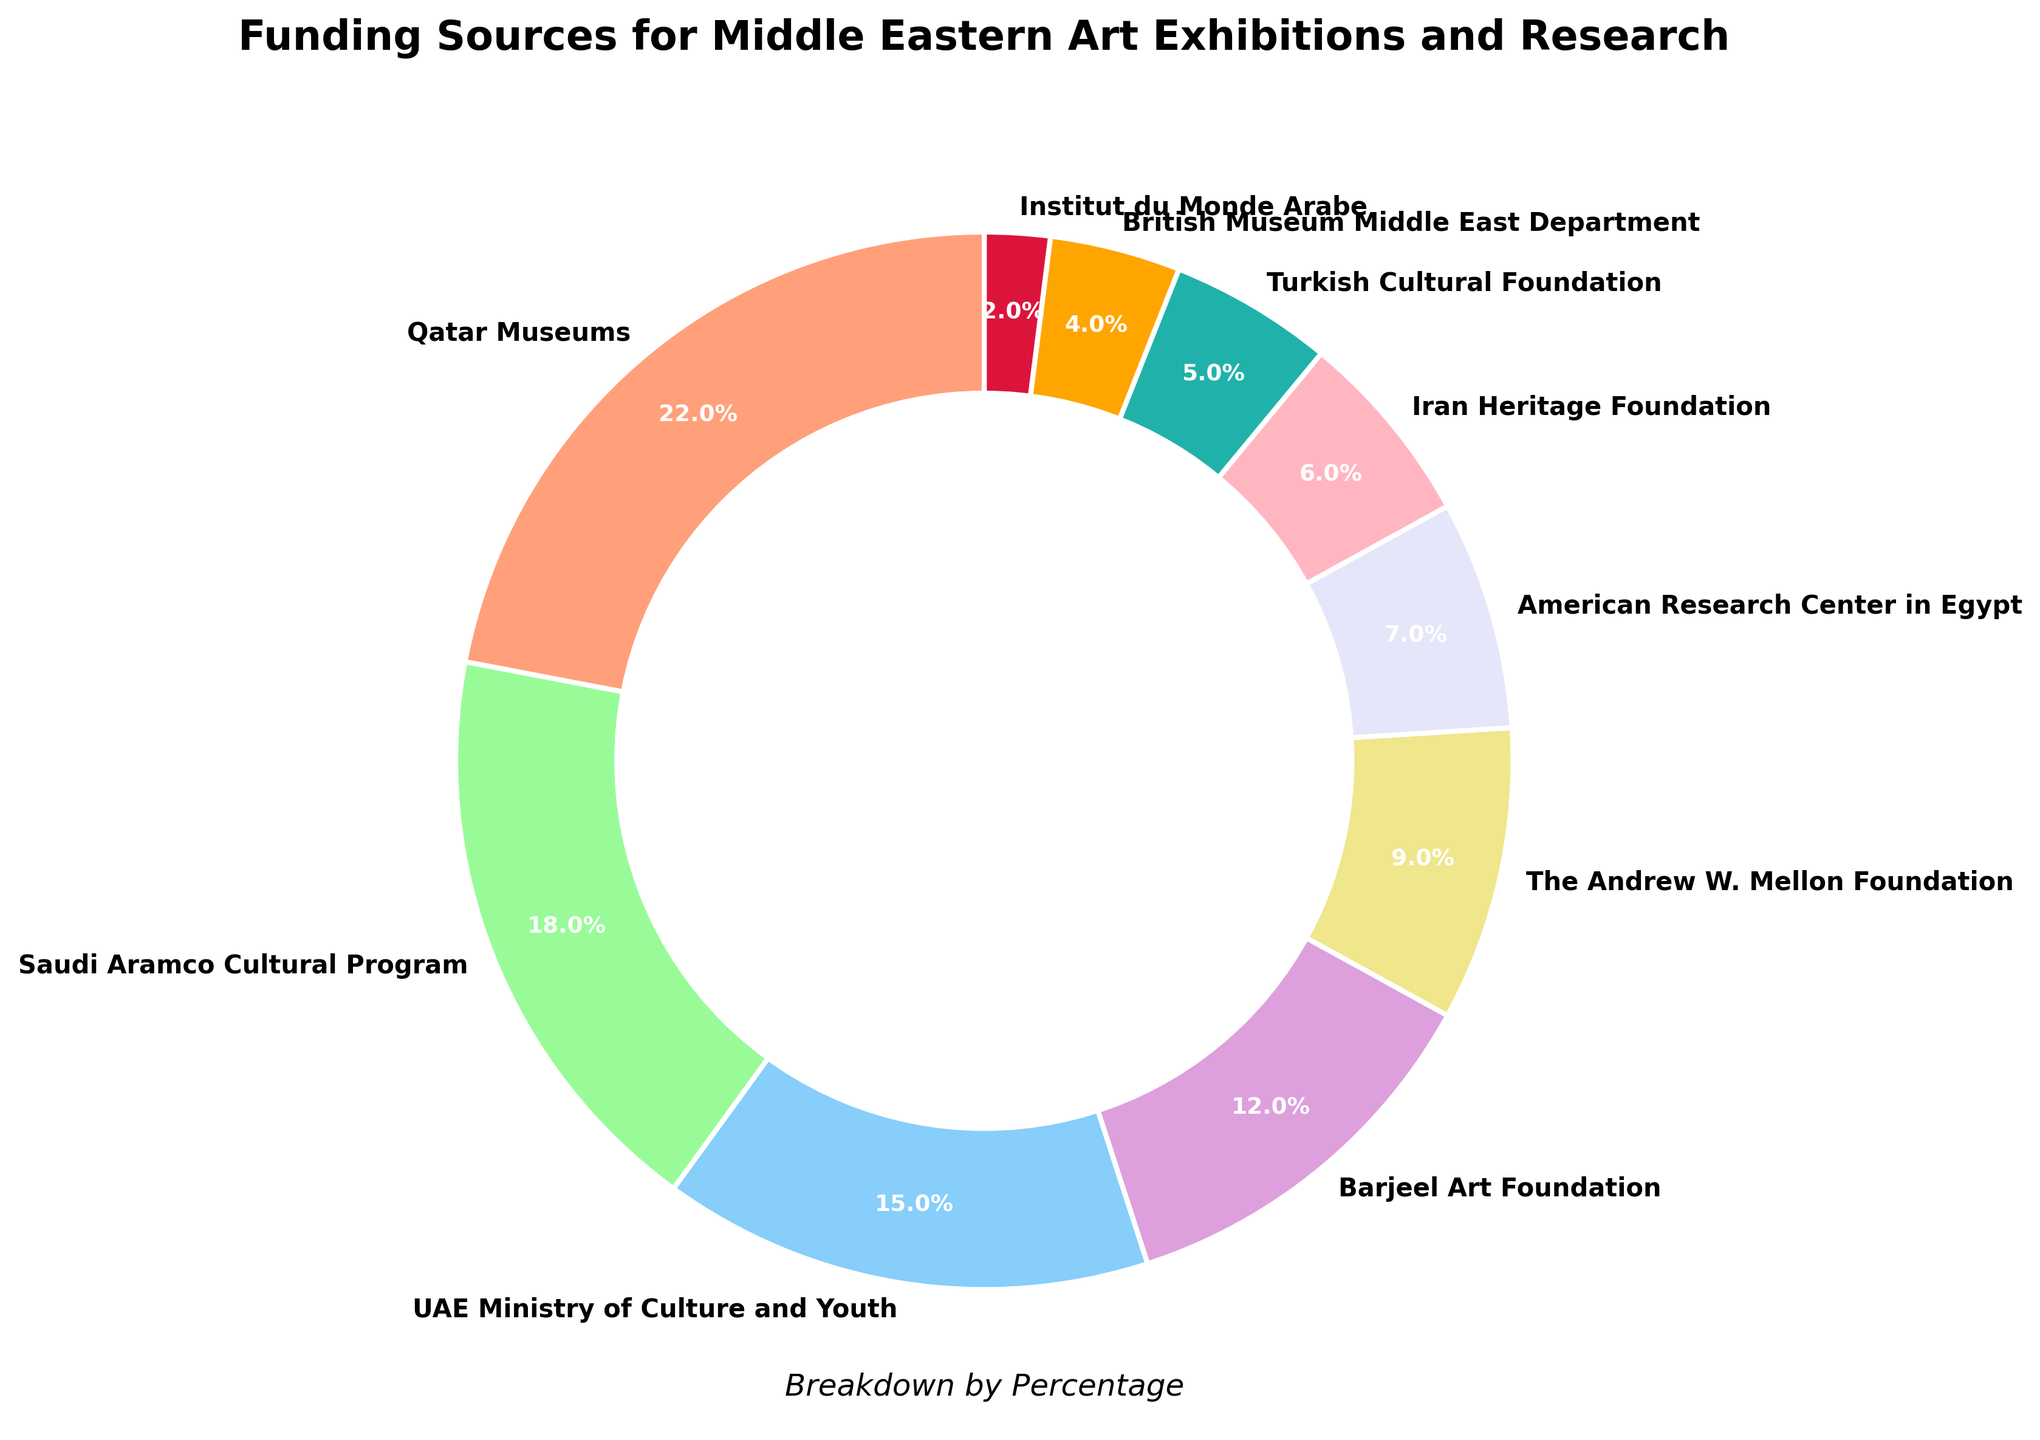What is the percentage of funding provided by the Qatar Museums? Locate the label "Qatar Museums" on the pie chart, which shows the corresponding percentage as 22%.
Answer: 22% Which funding source contributes the least to Middle Eastern art exhibitions and research? Find the slice of the pie chart with the smallest percentage, labeled "Institut du Monde Arabe," contributing 2%.
Answer: Institut du Monde Arabe How much more funding does the Qatar Museums provide compared to the British Museum Middle East Department? Subtract the percentage of the British Museum Middle East Department (4%) from the Qatar Museums (22%). The difference is 22% - 4% = 18%.
Answer: 18% What is the total percentage of funding from non-Middle Eastern sources? Sum the percentages of The Andrew W. Mellon Foundation (9%), American Research Center in Egypt (7%), and Institut du Monde Arabe (2%) which totals 9% + 7% + 2% = 18%.
Answer: 18% Which three funding sources contribute the most to Middle Eastern art exhibitions and research? Identify the top three largest slices on the pie chart. The largest slices are Qatar Museums (22%), Saudi Aramco Cultural Program (18%), and UAE Ministry of Culture and Youth (15%).
Answer: Qatar Museums, Saudi Aramco Cultural Program, UAE Ministry of Culture and Youth Is the funding from the Barjeel Art Foundation greater or smaller than the combined funding from the British Museum Middle East Department and the Turkish Cultural Foundation? Compare the funding percentages: Barjeel Art Foundation (12%) vs. British Museum Middle East Department (4%) + Turkish Cultural Foundation (5%). Hence, 12% vs. 4% + 5% = 9%. The Barjeel Art Foundation provides more.
Answer: Greater What is the cumulative percentage of funding from Qatar Museums, Saudi Aramco Cultural Program, and UAE Ministry of Culture and Youth? Sum the percentages: Qatar Museums (22%), Saudi Aramco Cultural Program (18%), UAE Ministry of Culture and Youth (15%), which totals 22% + 18% + 15% = 55%.
Answer: 55% Which funding source is represented with a green slice on the pie chart? Locate the slice with a green color, labeled "Saudi Aramco Cultural Program."
Answer: Saudi Aramco Cultural Program Are there more funding sources contributing above or below 10%? Count the funding sources with percentages: above 10% are Qatar Museums (22%), Saudi Aramco Cultural Program (18%), UAE Ministry of Culture and Youth (15%), Barjeel Art Foundation (12%) = 4 sources; below 10% are The Andrew W. Mellon Foundation (9%), American Research Center in Egypt (7%), Iran Heritage Foundation (6%), Turkish Cultural Foundation (5%), British Museum Middle East Department (4%), Institut du Monde Arabe (2%) = 6 sources. More sources are contributing below 10%.
Answer: Below 10% 